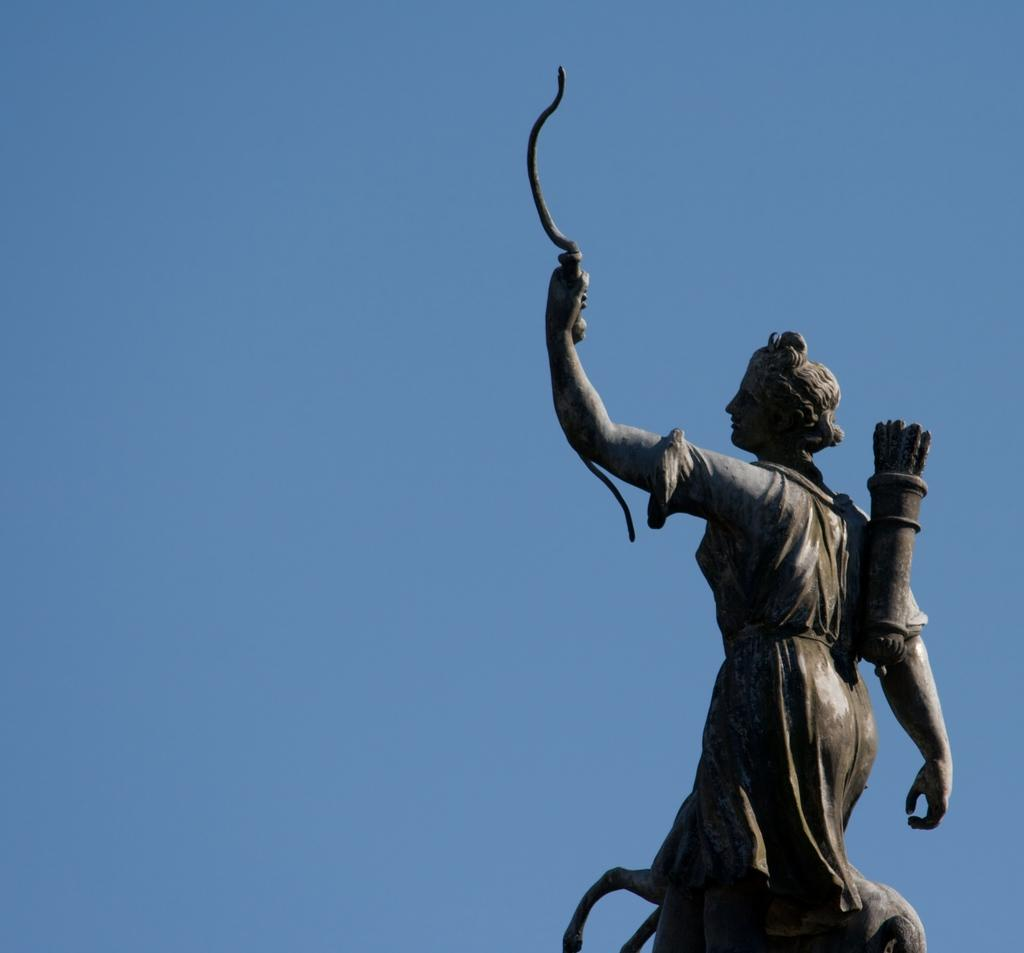What is the main subject of the image? There is a sculpture of a person in the image. What can be seen behind the sculpture? The sky is visible behind the sculpture. How many cakes are being served by the person in the sculpture? There is no mention of cakes or any serving activity in the image; it features a sculpture of a person with the sky visible behind it. 